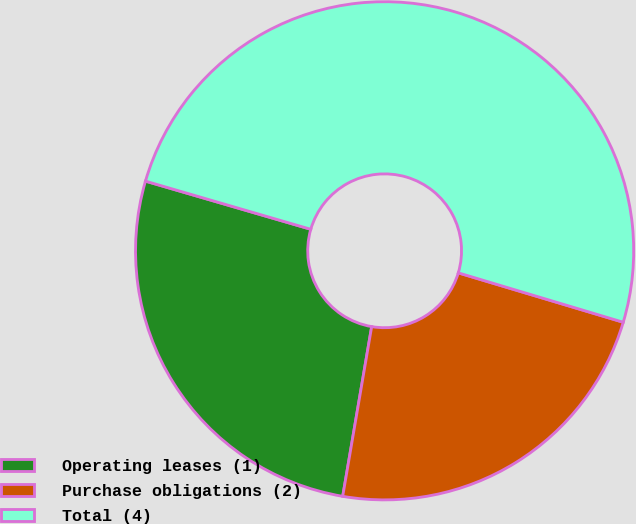<chart> <loc_0><loc_0><loc_500><loc_500><pie_chart><fcel>Operating leases (1)<fcel>Purchase obligations (2)<fcel>Total (4)<nl><fcel>26.82%<fcel>23.06%<fcel>50.12%<nl></chart> 